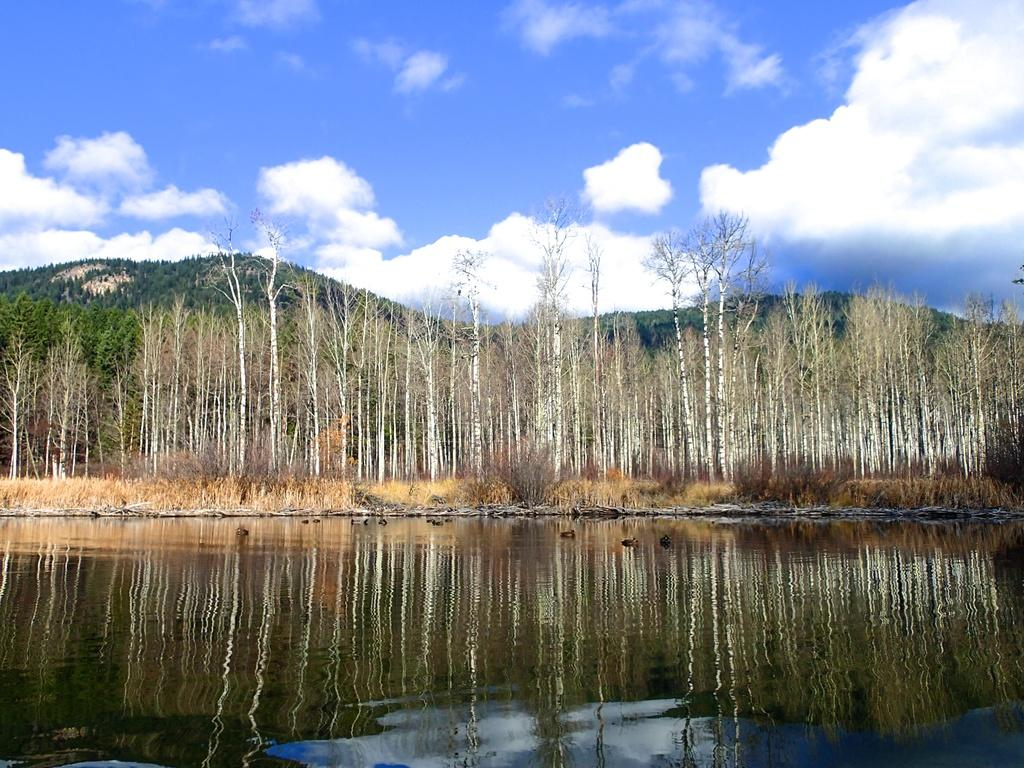What type of natural environment is depicted in the image? The image features water, grass, trees, and mountains, which are all elements of a natural environment. What type of vegetation can be seen in the image? There are trees and grass visible in the image. What is the condition of the sky in the image? The sky is visible in the image, and there are clouds present. Can you see a rat using a net to catch fish in the image? There is no rat or net present in the image, and therefore no such activity can be observed. 